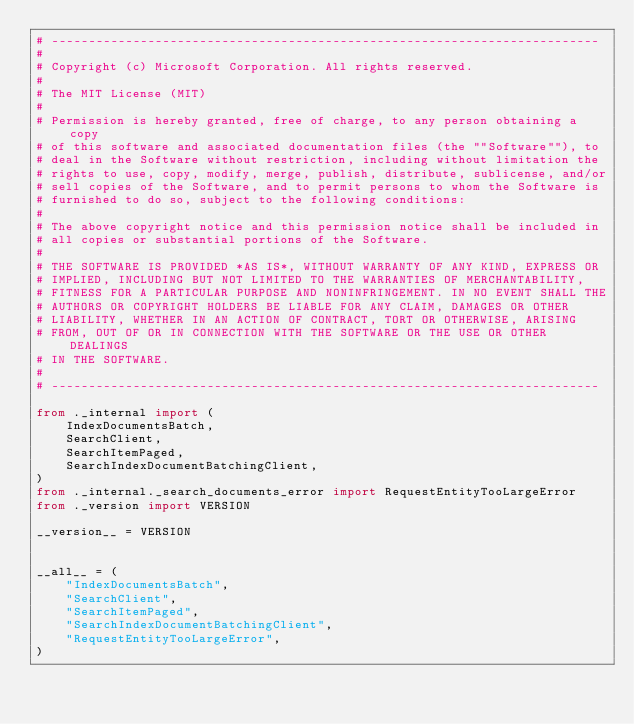<code> <loc_0><loc_0><loc_500><loc_500><_Python_># --------------------------------------------------------------------------
#
# Copyright (c) Microsoft Corporation. All rights reserved.
#
# The MIT License (MIT)
#
# Permission is hereby granted, free of charge, to any person obtaining a copy
# of this software and associated documentation files (the ""Software""), to
# deal in the Software without restriction, including without limitation the
# rights to use, copy, modify, merge, publish, distribute, sublicense, and/or
# sell copies of the Software, and to permit persons to whom the Software is
# furnished to do so, subject to the following conditions:
#
# The above copyright notice and this permission notice shall be included in
# all copies or substantial portions of the Software.
#
# THE SOFTWARE IS PROVIDED *AS IS*, WITHOUT WARRANTY OF ANY KIND, EXPRESS OR
# IMPLIED, INCLUDING BUT NOT LIMITED TO THE WARRANTIES OF MERCHANTABILITY,
# FITNESS FOR A PARTICULAR PURPOSE AND NONINFRINGEMENT. IN NO EVENT SHALL THE
# AUTHORS OR COPYRIGHT HOLDERS BE LIABLE FOR ANY CLAIM, DAMAGES OR OTHER
# LIABILITY, WHETHER IN AN ACTION OF CONTRACT, TORT OR OTHERWISE, ARISING
# FROM, OUT OF OR IN CONNECTION WITH THE SOFTWARE OR THE USE OR OTHER DEALINGS
# IN THE SOFTWARE.
#
# --------------------------------------------------------------------------

from ._internal import (
    IndexDocumentsBatch,
    SearchClient,
    SearchItemPaged,
    SearchIndexDocumentBatchingClient,
)
from ._internal._search_documents_error import RequestEntityTooLargeError
from ._version import VERSION

__version__ = VERSION


__all__ = (
    "IndexDocumentsBatch",
    "SearchClient",
    "SearchItemPaged",
    "SearchIndexDocumentBatchingClient",
    "RequestEntityTooLargeError",
)
</code> 